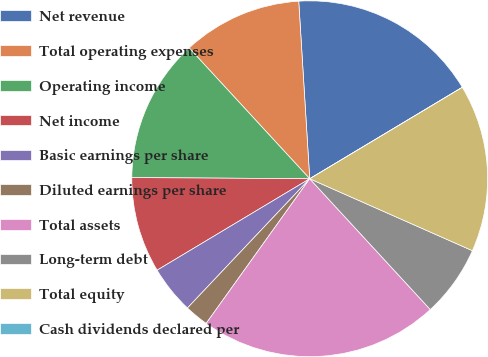<chart> <loc_0><loc_0><loc_500><loc_500><pie_chart><fcel>Net revenue<fcel>Total operating expenses<fcel>Operating income<fcel>Net income<fcel>Basic earnings per share<fcel>Diluted earnings per share<fcel>Total assets<fcel>Long-term debt<fcel>Total equity<fcel>Cash dividends declared per<nl><fcel>17.39%<fcel>10.87%<fcel>13.04%<fcel>8.7%<fcel>4.35%<fcel>2.17%<fcel>21.74%<fcel>6.52%<fcel>15.22%<fcel>0.0%<nl></chart> 